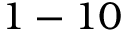<formula> <loc_0><loc_0><loc_500><loc_500>1 - 1 0</formula> 